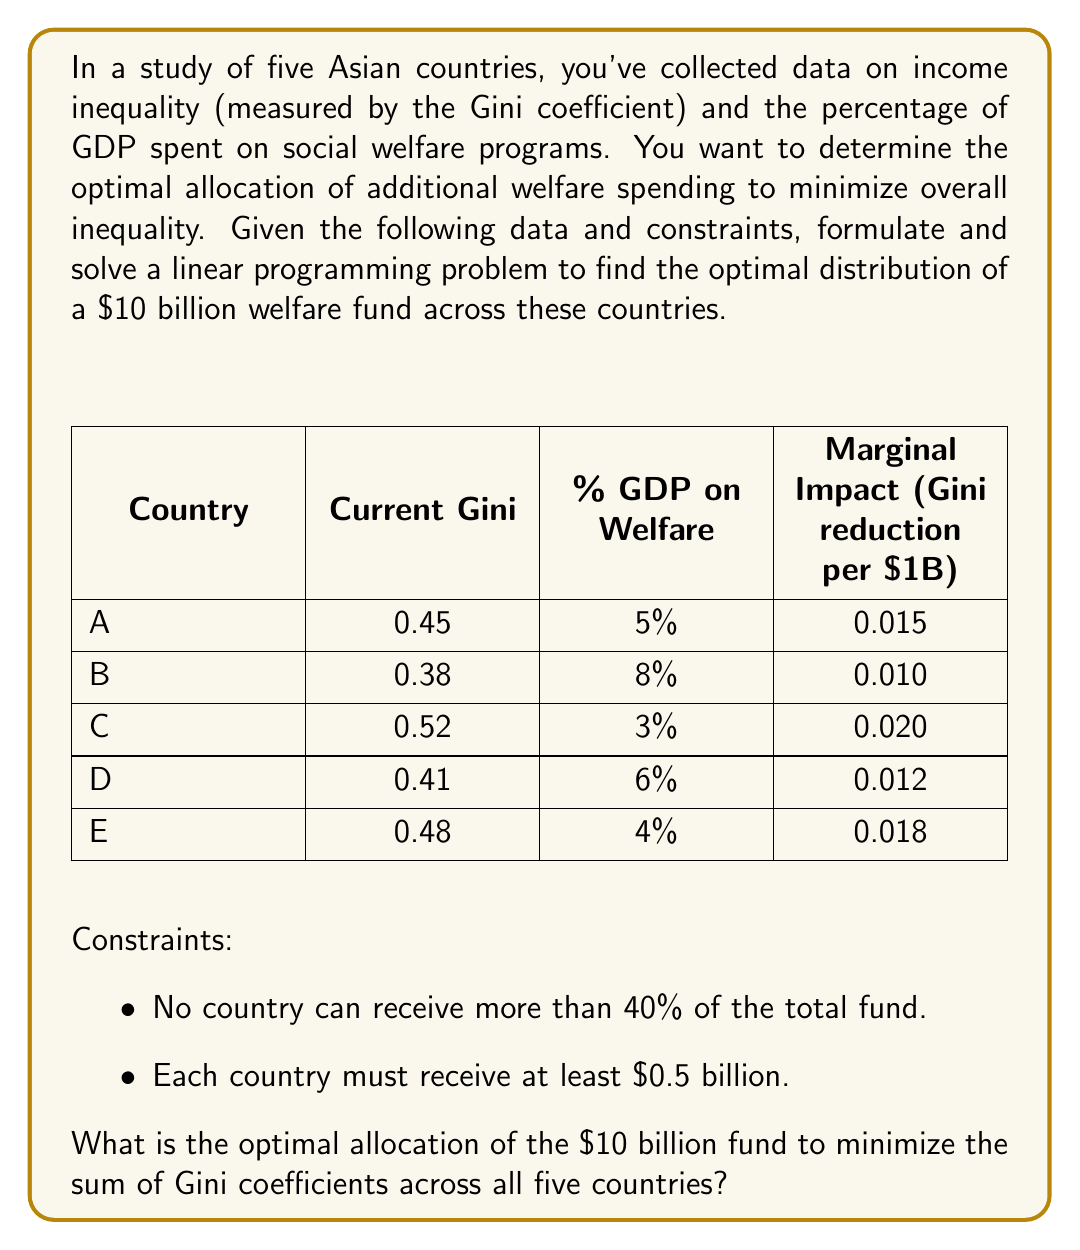Provide a solution to this math problem. To solve this linear programming problem, we need to:

1. Define variables:
Let $x_i$ represent the amount of funding (in billions) allocated to country $i$, where $i \in \{A, B, C, D, E\}$.

2. Set up the objective function:
We want to minimize the sum of Gini coefficients after the intervention. The new Gini for each country will be:
Current Gini - (Marginal Impact × Allocated Funding)

Objective function:
$$\min Z = (0.45 - 0.015x_A) + (0.38 - 0.010x_B) + (0.52 - 0.020x_C) + (0.41 - 0.012x_D) + (0.48 - 0.018x_E)$$

3. Define constraints:
a) Total funding constraint: $x_A + x_B + x_C + x_D + x_E = 10$
b) Maximum allocation constraint: $x_i \leq 4$ for all $i$
c) Minimum allocation constraint: $x_i \geq 0.5$ for all $i$
d) Non-negativity: $x_i \geq 0$ for all $i$

4. Solve the linear programming problem:
Using a linear programming solver (e.g., simplex method), we obtain the optimal solution:

$x_A = 0.5$
$x_B = 0.5$
$x_C = 4.0$
$x_D = 0.5$
$x_E = 4.5$

5. Verify constraints:
- Total funding: $0.5 + 0.5 + 4.0 + 0.5 + 4.5 = 10$ (satisfied)
- Maximum allocation: No country exceeds $4 billion (satisfied)
- Minimum allocation: Each country receives at least $0.5 billion (satisfied)

6. Calculate the new Gini coefficients:
A: $0.45 - (0.015 \times 0.5) = 0.4425$
B: $0.38 - (0.010 \times 0.5) = 0.3750$
C: $0.52 - (0.020 \times 4.0) = 0.4400$
D: $0.41 - (0.012 \times 0.5) = 0.4040$
E: $0.48 - (0.018 \times 4.5) = 0.3990$

Sum of new Gini coefficients: $2.0605$
Answer: The optimal allocation of the $10 billion fund to minimize the sum of Gini coefficients is:
Country A: $0.5 billion
Country B: $0.5 billion
Country C: $4.0 billion
Country D: $0.5 billion
Country E: $4.5 billion
This allocation results in a minimized sum of Gini coefficients of 2.0605. 